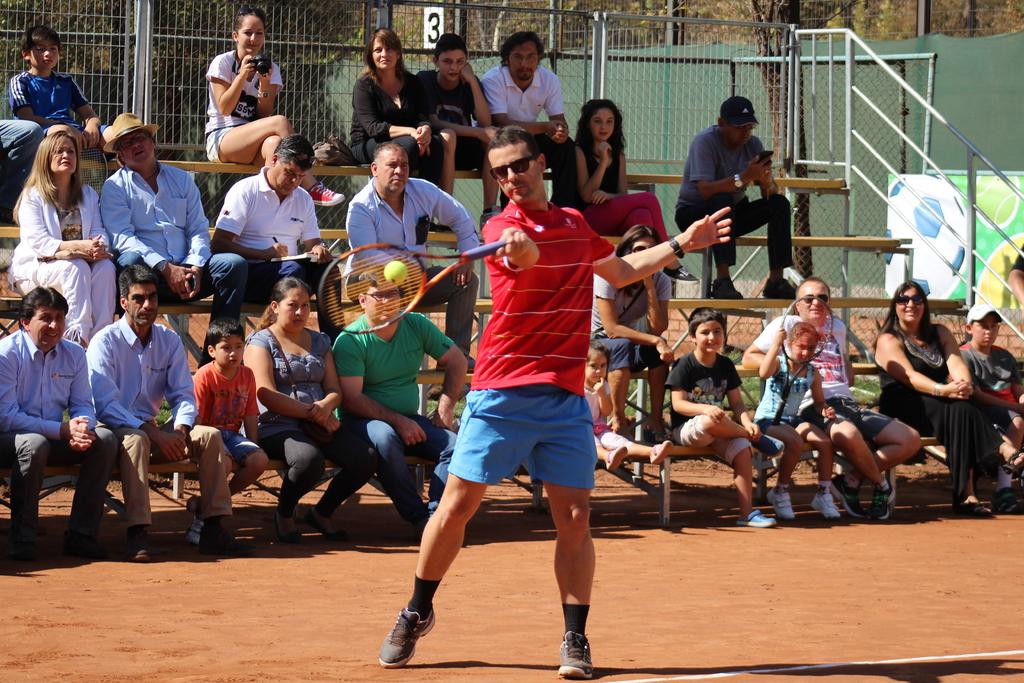What number is on the fence behind the man in black clothing?
Your answer should be very brief. 3. 